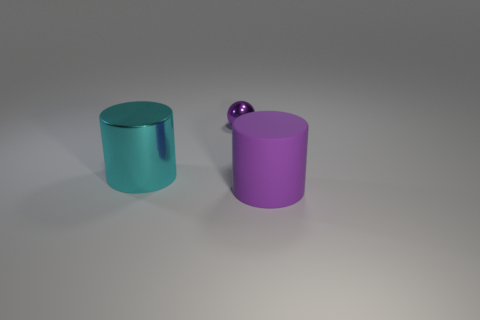Add 1 large cyan metal cylinders. How many objects exist? 4 Subtract 1 purple cylinders. How many objects are left? 2 Subtract all balls. How many objects are left? 2 Subtract all big cyan cylinders. Subtract all small rubber cylinders. How many objects are left? 2 Add 1 shiny objects. How many shiny objects are left? 3 Add 1 large matte cylinders. How many large matte cylinders exist? 2 